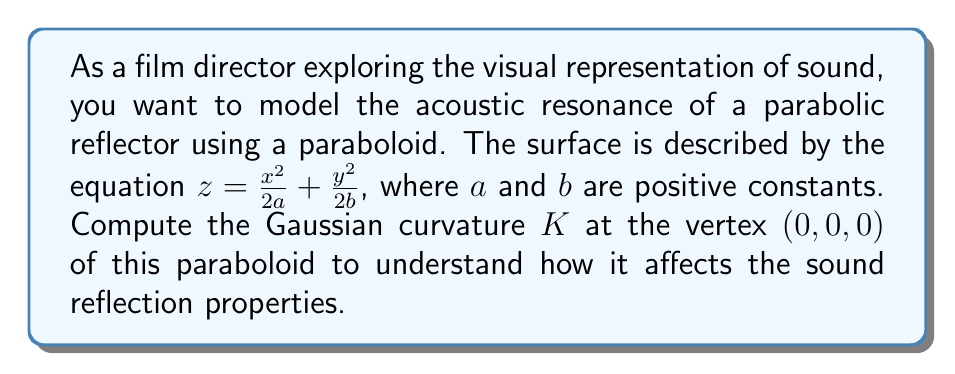Solve this math problem. To compute the Gaussian curvature of the paraboloid, we'll follow these steps:

1) The paraboloid is given by $z = \frac{x^2}{2a} + \frac{y^2}{2b}$. We can parametrize this surface as:
   
   $\mathbf{r}(x,y) = (x, y, \frac{x^2}{2a} + \frac{y^2}{2b})$

2) Calculate the partial derivatives:
   $\mathbf{r}_x = (1, 0, \frac{x}{a})$
   $\mathbf{r}_y = (0, 1, \frac{y}{b})$

3) The coefficients of the first fundamental form are:
   $E = \mathbf{r}_x \cdot \mathbf{r}_x = 1 + \frac{x^2}{a^2}$
   $F = \mathbf{r}_x \cdot \mathbf{r}_y = \frac{xy}{ab}$
   $G = \mathbf{r}_y \cdot \mathbf{r}_y = 1 + \frac{y^2}{b^2}$

4) Calculate the second partial derivatives:
   $\mathbf{r}_{xx} = (0, 0, \frac{1}{a})$
   $\mathbf{r}_{xy} = (0, 0, 0)$
   $\mathbf{r}_{yy} = (0, 0, \frac{1}{b})$

5) The unit normal vector is:
   $\mathbf{N} = \frac{\mathbf{r}_x \times \mathbf{r}_y}{|\mathbf{r}_x \times \mathbf{r}_y|} = \frac{(-\frac{x}{a}, -\frac{y}{b}, 1)}{\sqrt{1 + \frac{x^2}{a^2} + \frac{y^2}{b^2}}}$

6) The coefficients of the second fundamental form are:
   $L = \mathbf{r}_{xx} \cdot \mathbf{N} = \frac{1}{a\sqrt{1 + \frac{x^2}{a^2} + \frac{y^2}{b^2}}}$
   $M = \mathbf{r}_{xy} \cdot \mathbf{N} = 0$
   $N = \mathbf{r}_{yy} \cdot \mathbf{N} = \frac{1}{b\sqrt{1 + \frac{x^2}{a^2} + \frac{y^2}{b^2}}}$

7) The Gaussian curvature is given by:
   $K = \frac{LN - M^2}{EG - F^2}$

8) At the vertex (0, 0, 0), we have:
   $E = G = 1$, $F = 0$
   $L = \frac{1}{a}$, $M = 0$, $N = \frac{1}{b}$

9) Substituting these values:
   $K = \frac{(\frac{1}{a})(\frac{1}{b}) - 0^2}{(1)(1) - 0^2} = \frac{1}{ab}$

Therefore, the Gaussian curvature at the vertex of the paraboloid is $\frac{1}{ab}$.
Answer: $K = \frac{1}{ab}$ 